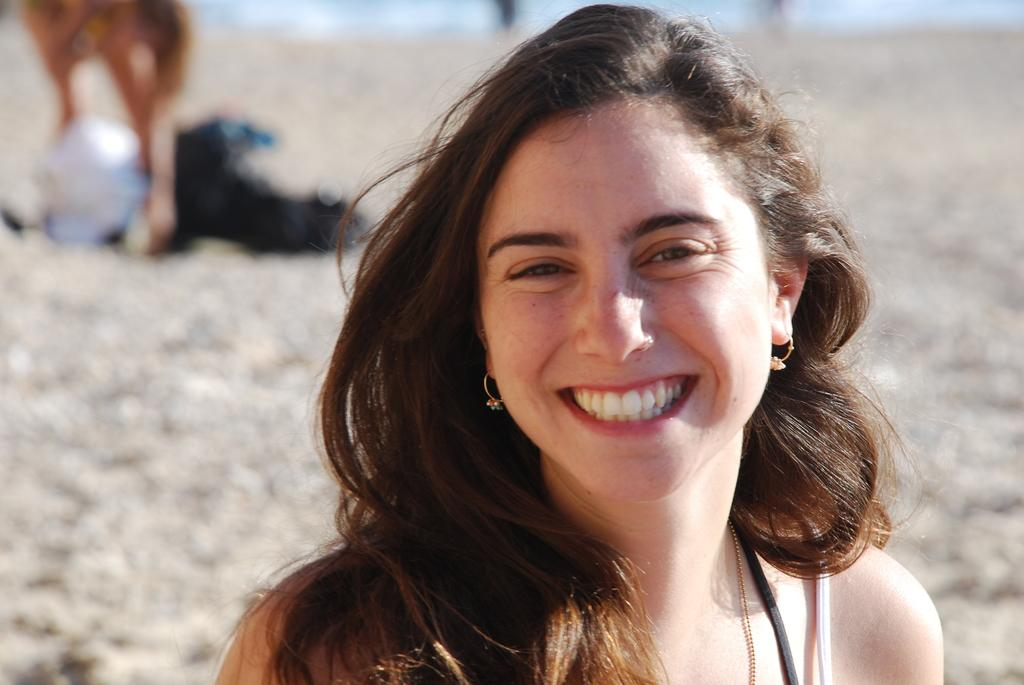Who is present in the image? There is a woman in the image. What is the woman's facial expression? The woman is smiling. Can you describe the background of the image? The background of the image is blurred. What type of frogs can be seen in the background of the image? There are no frogs present in the image; the background is blurred. What does the woman feel shame about in the image? There is no indication in the image that the woman feels shame about anything. 